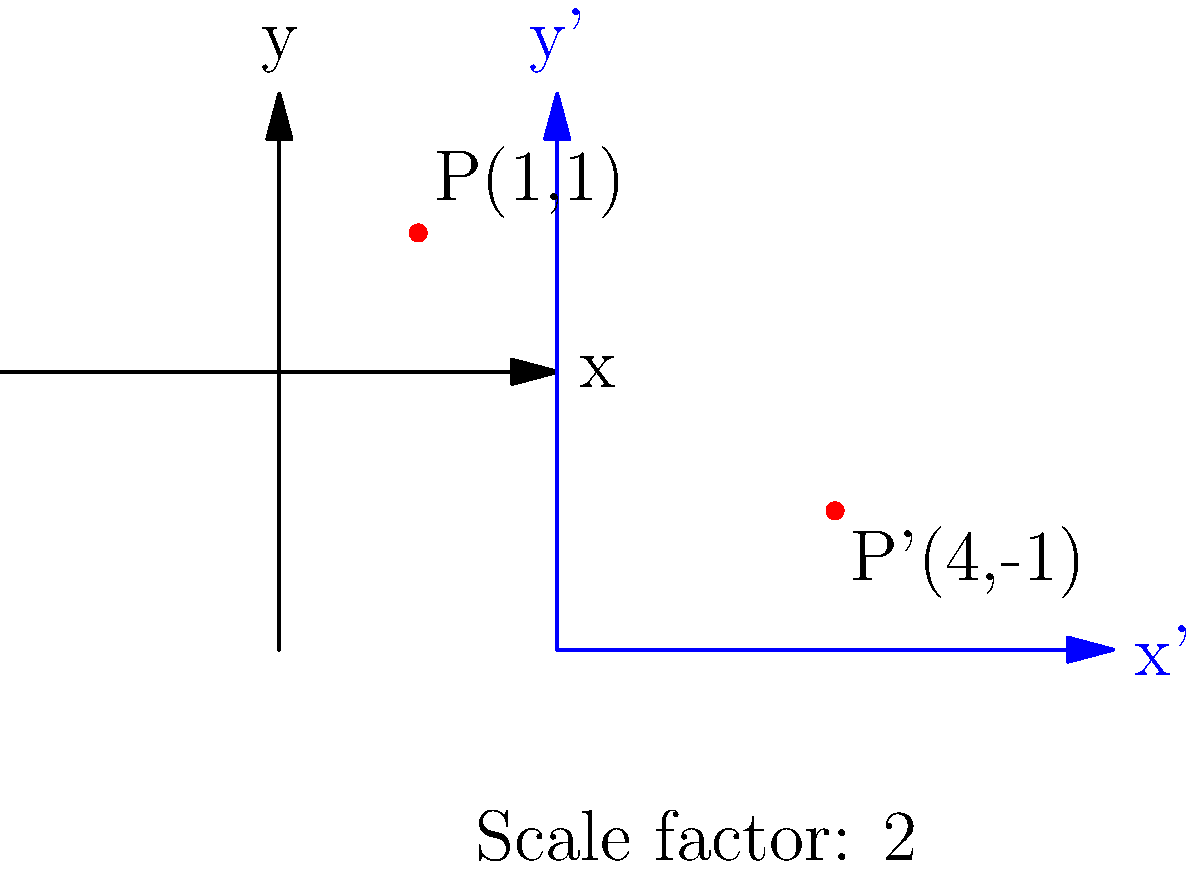Consider a coordinate system transformation where the x-axis is scaled by a factor of 2 and the y-axis is scaled by a factor of -1. How does this transformation affect the complexity of a simple substitution cipher that uses the coordinates of points as part of its encryption process? Explain the impact on both encryption and decryption. To understand the impact of this scaling transformation on cipher complexity, let's break it down step-by-step:

1. Original transformation:
   $T(x, y) = (2x, -y)$

2. Effect on point coordinates:
   - Original point $P(1, 1)$ becomes $P'(2, -1)$
   - General point $(x, y)$ becomes $(2x, -y)$

3. Impact on encryption:
   a) The transformation doubles the range of x-coordinates and inverts y-coordinates.
   b) This increases the keyspace for the cipher, as there are more possible coordinate pairs.
   c) The linear nature of the transformation maintains relative distances between points, preserving some patterns.

4. Impact on decryption:
   a) To decrypt, we need the inverse transformation: $T^{-1}(x', y') = (\frac{x'}{2}, -y')$
   b) This inverse transformation is also linear and easy to compute.

5. Overall complexity change:
   a) The keyspace is increased, potentially making brute-force attacks more time-consuming.
   b) However, the linear nature of the transformation preserves structural properties of the original coordinate system.
   c) Statistical analysis techniques may still be effective due to the preserved relative distances.

6. Cryptanalysis considerations:
   a) Frequency analysis might still be applicable if the cipher relies on letter frequencies mapped to coordinates.
   b) The scaling factor (2 for x, -1 for y) could potentially be deduced by analyzing the distribution of transformed coordinates.

In conclusion, while the transformation increases the keyspace and adds a layer of complexity, it doesn't fundamentally alter the cipher's security against advanced cryptanalysis techniques due to its linear nature and preservation of relative distances.
Answer: Increased keyspace but preserved linear properties; moderately increased complexity 